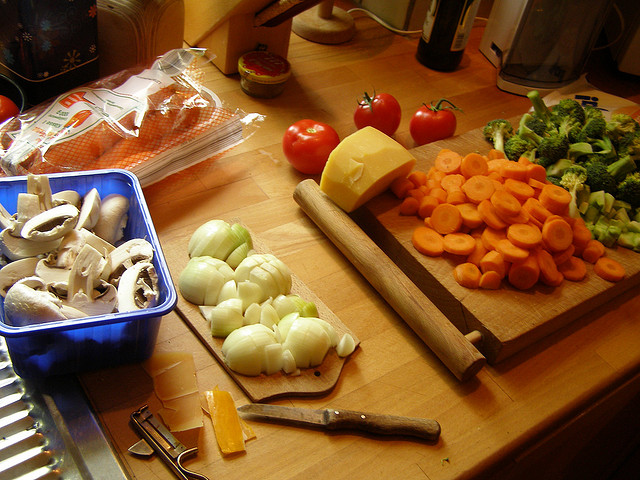What kind of meal seems to be prepared with the ingredients shown? It looks like the ingredients laid out, including mushrooms, tomatoes, broccoli, onions, and carrots, might be used for making a vegetable stir-fry or a similar dish where fresh vegetables are the main components. Are all the vegetables on the cutting board already chopped? Yes, the onions and carrots have been peeled and chopped, the broccoli is cut into florets, and it seems like the mushrooms are ready to be sliced as well. 